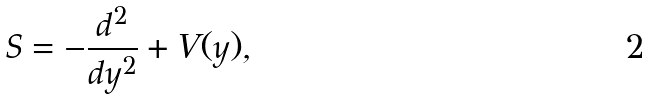Convert formula to latex. <formula><loc_0><loc_0><loc_500><loc_500>S = - \frac { d ^ { 2 } } { d y ^ { 2 } } + V ( y ) ,</formula> 